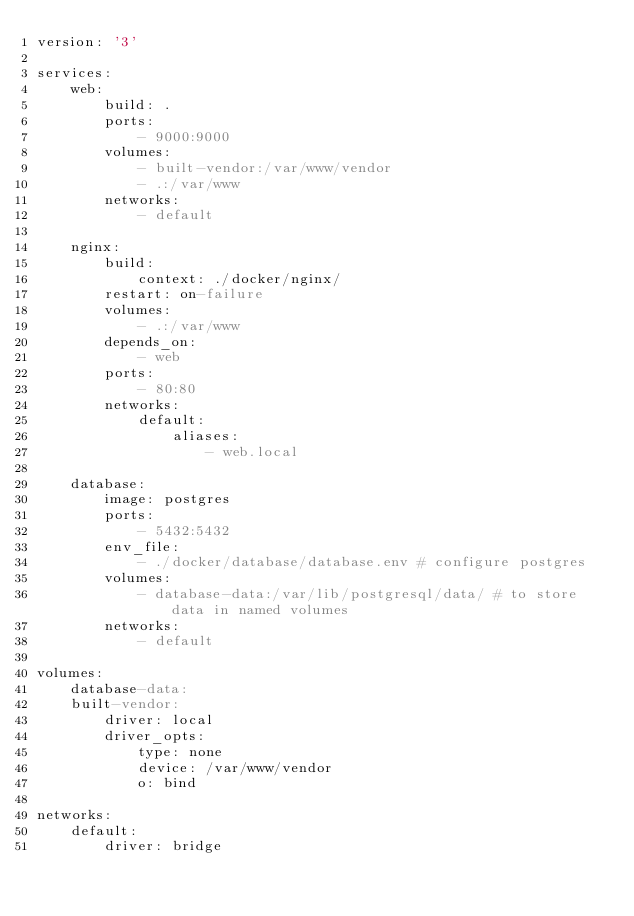<code> <loc_0><loc_0><loc_500><loc_500><_YAML_>version: '3'

services:
    web:
        build: .
        ports:
            - 9000:9000
        volumes:
            - built-vendor:/var/www/vendor
            - .:/var/www
        networks:
            - default

    nginx:
        build:
            context: ./docker/nginx/
        restart: on-failure
        volumes:
            - .:/var/www
        depends_on:
            - web
        ports:
            - 80:80
        networks:
            default:
                aliases:
                    - web.local

    database:
        image: postgres
        ports:
            - 5432:5432
        env_file:
            - ./docker/database/database.env # configure postgres
        volumes:
            - database-data:/var/lib/postgresql/data/ # to store data in named volumes
        networks:
            - default

volumes:
    database-data:
    built-vendor:
        driver: local
        driver_opts:
            type: none
            device: /var/www/vendor
            o: bind

networks:
    default:
        driver: bridge</code> 